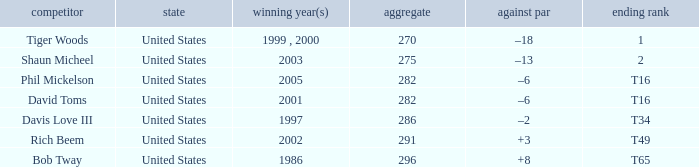In which year(s) did the person who has a total of 291 win? 2002.0. 